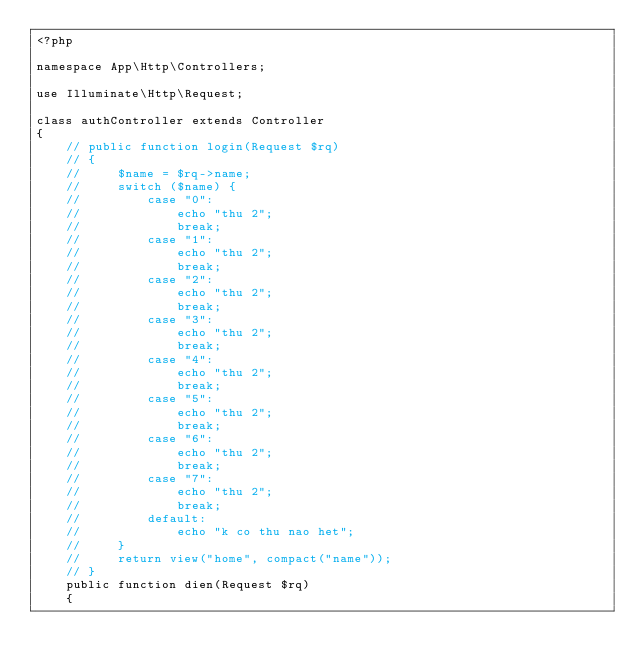Convert code to text. <code><loc_0><loc_0><loc_500><loc_500><_PHP_><?php

namespace App\Http\Controllers;

use Illuminate\Http\Request;

class authController extends Controller
{
    // public function login(Request $rq)
    // {
    //     $name = $rq->name;
    //     switch ($name) {
    //         case "0":
    //             echo "thu 2";
    //             break;
    //         case "1":
    //             echo "thu 2";
    //             break;
    //         case "2":
    //             echo "thu 2";
    //             break;
    //         case "3":
    //             echo "thu 2";
    //             break;
    //         case "4":
    //             echo "thu 2";
    //             break;
    //         case "5":
    //             echo "thu 2";
    //             break;
    //         case "6":
    //             echo "thu 2";
    //             break;
    //         case "7":
    //             echo "thu 2";
    //             break;
    //         default:
    //             echo "k co thu nao het";
    //     }
    //     return view("home", compact("name"));
    // }
    public function dien(Request $rq)
    {</code> 